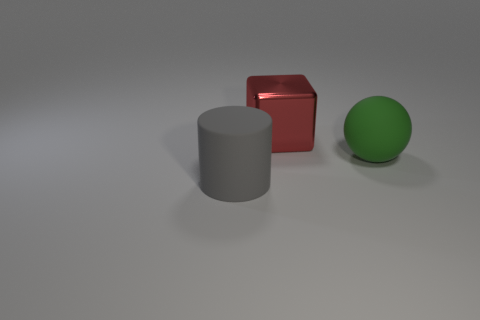Subtract 1 blocks. How many blocks are left? 0 Add 2 metal things. How many objects exist? 5 Subtract all blocks. How many objects are left? 2 Subtract all brown cylinders. Subtract all yellow blocks. How many cylinders are left? 1 Subtract all purple cylinders. How many gray blocks are left? 0 Subtract all green objects. Subtract all spheres. How many objects are left? 1 Add 3 large green spheres. How many large green spheres are left? 4 Add 1 red things. How many red things exist? 2 Subtract 0 blue spheres. How many objects are left? 3 